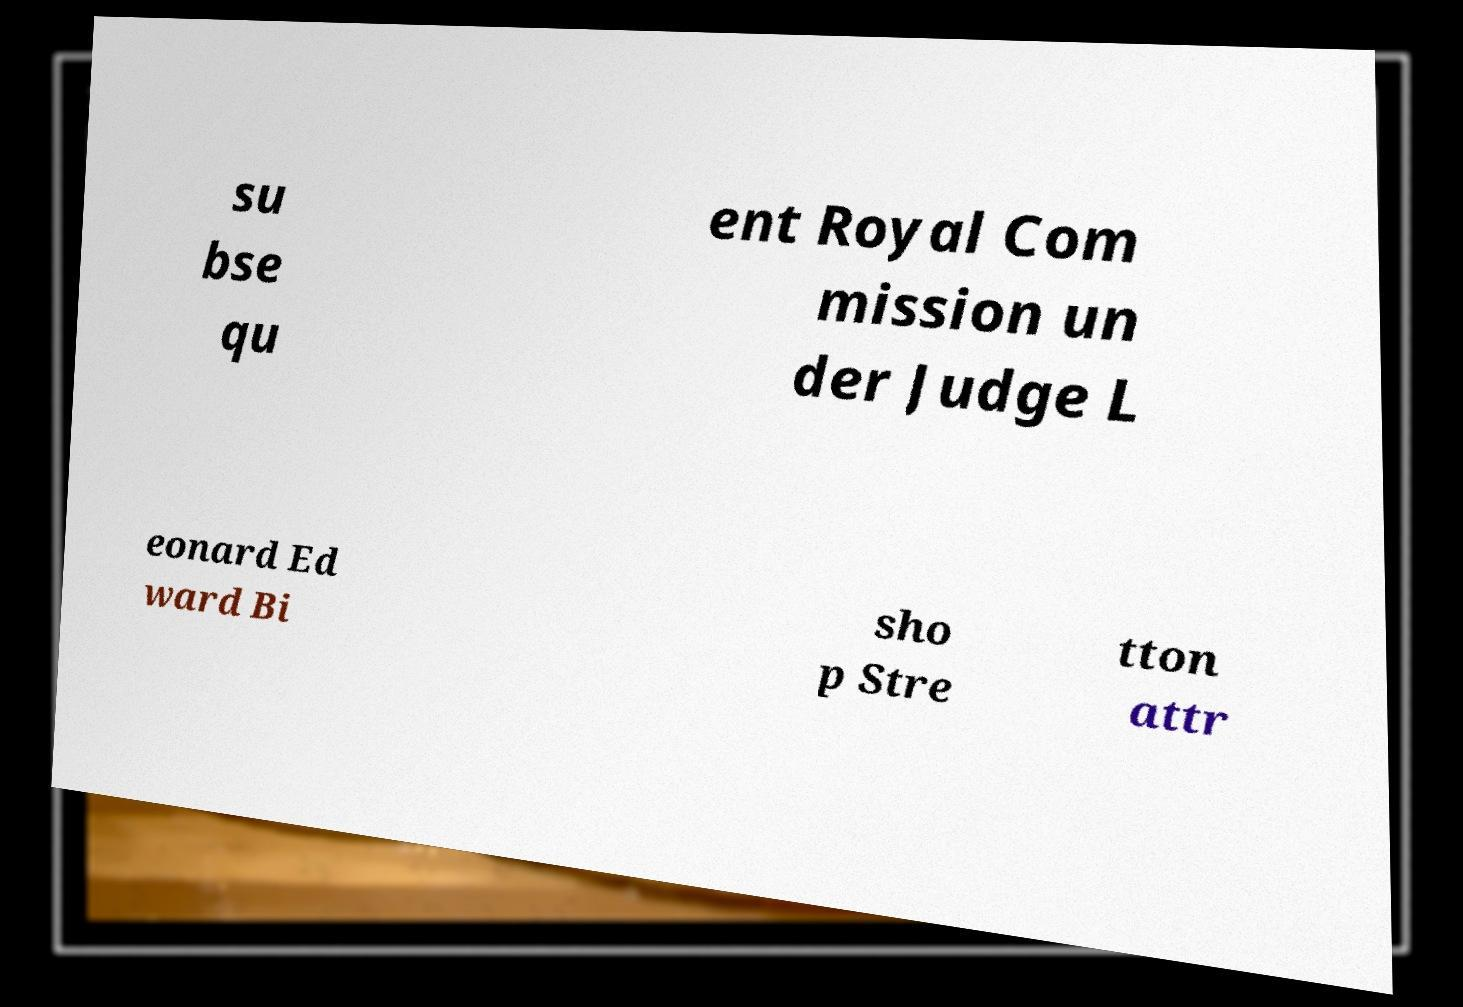I need the written content from this picture converted into text. Can you do that? su bse qu ent Royal Com mission un der Judge L eonard Ed ward Bi sho p Stre tton attr 